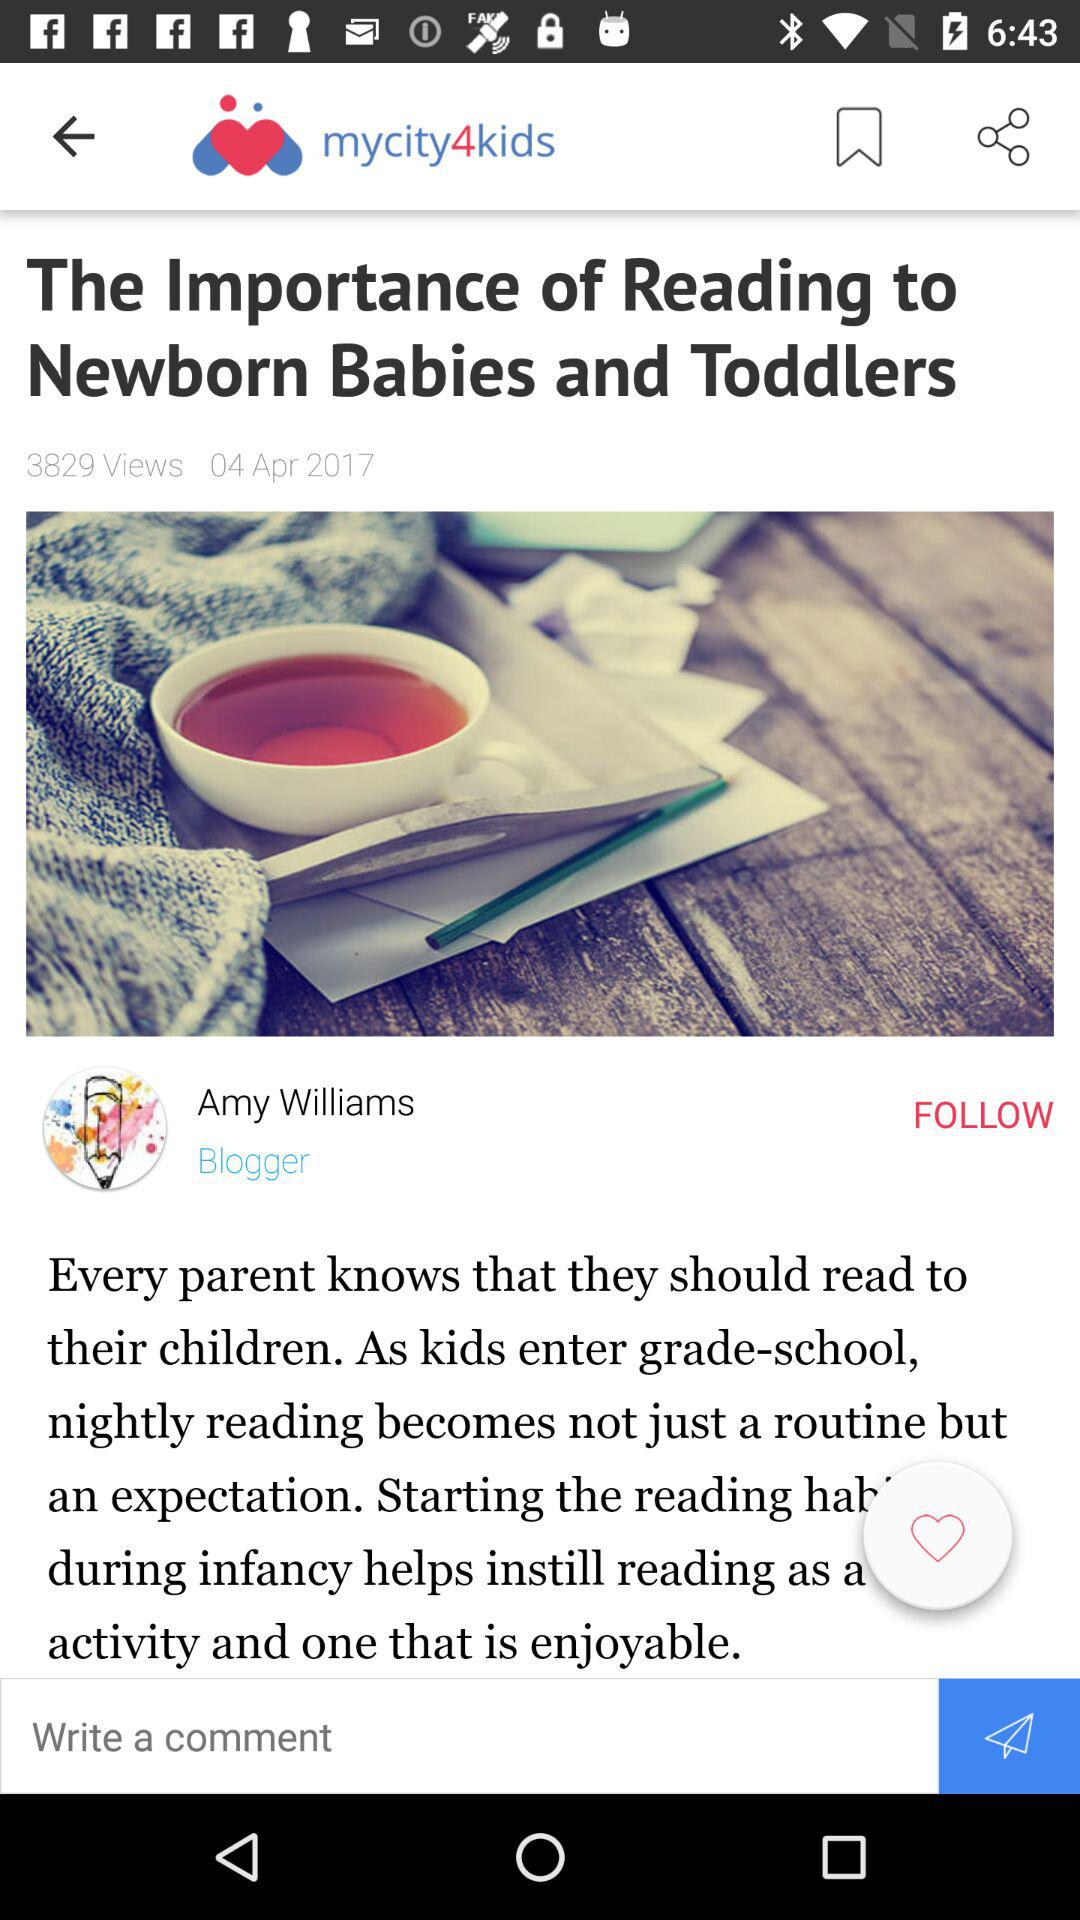What is the mentioned date? The mentioned date is April 4, 2017. 